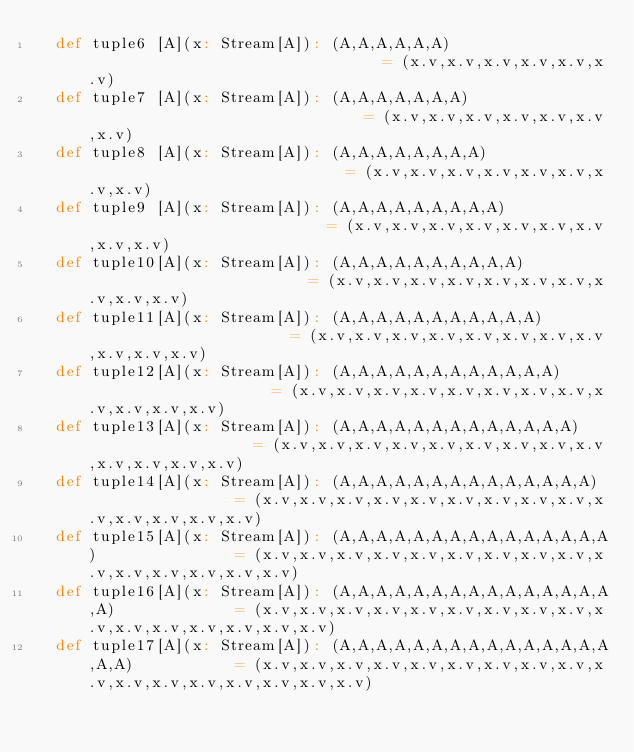Convert code to text. <code><loc_0><loc_0><loc_500><loc_500><_Scala_>  def tuple6 [A](x: Stream[A]): (A,A,A,A,A,A)                                 = (x.v,x.v,x.v,x.v,x.v,x.v)
  def tuple7 [A](x: Stream[A]): (A,A,A,A,A,A,A)                               = (x.v,x.v,x.v,x.v,x.v,x.v,x.v)
  def tuple8 [A](x: Stream[A]): (A,A,A,A,A,A,A,A)                             = (x.v,x.v,x.v,x.v,x.v,x.v,x.v,x.v)
  def tuple9 [A](x: Stream[A]): (A,A,A,A,A,A,A,A,A)                           = (x.v,x.v,x.v,x.v,x.v,x.v,x.v,x.v,x.v)
  def tuple10[A](x: Stream[A]): (A,A,A,A,A,A,A,A,A,A)                         = (x.v,x.v,x.v,x.v,x.v,x.v,x.v,x.v,x.v,x.v)
  def tuple11[A](x: Stream[A]): (A,A,A,A,A,A,A,A,A,A,A)                       = (x.v,x.v,x.v,x.v,x.v,x.v,x.v,x.v,x.v,x.v,x.v)
  def tuple12[A](x: Stream[A]): (A,A,A,A,A,A,A,A,A,A,A,A)                     = (x.v,x.v,x.v,x.v,x.v,x.v,x.v,x.v,x.v,x.v,x.v,x.v)
  def tuple13[A](x: Stream[A]): (A,A,A,A,A,A,A,A,A,A,A,A,A)                   = (x.v,x.v,x.v,x.v,x.v,x.v,x.v,x.v,x.v,x.v,x.v,x.v,x.v)
  def tuple14[A](x: Stream[A]): (A,A,A,A,A,A,A,A,A,A,A,A,A,A)                 = (x.v,x.v,x.v,x.v,x.v,x.v,x.v,x.v,x.v,x.v,x.v,x.v,x.v,x.v)
  def tuple15[A](x: Stream[A]): (A,A,A,A,A,A,A,A,A,A,A,A,A,A,A)               = (x.v,x.v,x.v,x.v,x.v,x.v,x.v,x.v,x.v,x.v,x.v,x.v,x.v,x.v,x.v)
  def tuple16[A](x: Stream[A]): (A,A,A,A,A,A,A,A,A,A,A,A,A,A,A,A)             = (x.v,x.v,x.v,x.v,x.v,x.v,x.v,x.v,x.v,x.v,x.v,x.v,x.v,x.v,x.v,x.v)
  def tuple17[A](x: Stream[A]): (A,A,A,A,A,A,A,A,A,A,A,A,A,A,A,A,A)           = (x.v,x.v,x.v,x.v,x.v,x.v,x.v,x.v,x.v,x.v,x.v,x.v,x.v,x.v,x.v,x.v,x.v)</code> 